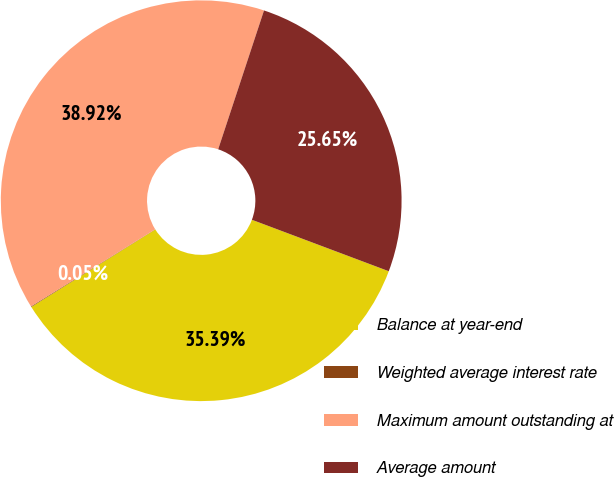Convert chart. <chart><loc_0><loc_0><loc_500><loc_500><pie_chart><fcel>Balance at year-end<fcel>Weighted average interest rate<fcel>Maximum amount outstanding at<fcel>Average amount<nl><fcel>35.39%<fcel>0.05%<fcel>38.92%<fcel>25.65%<nl></chart> 